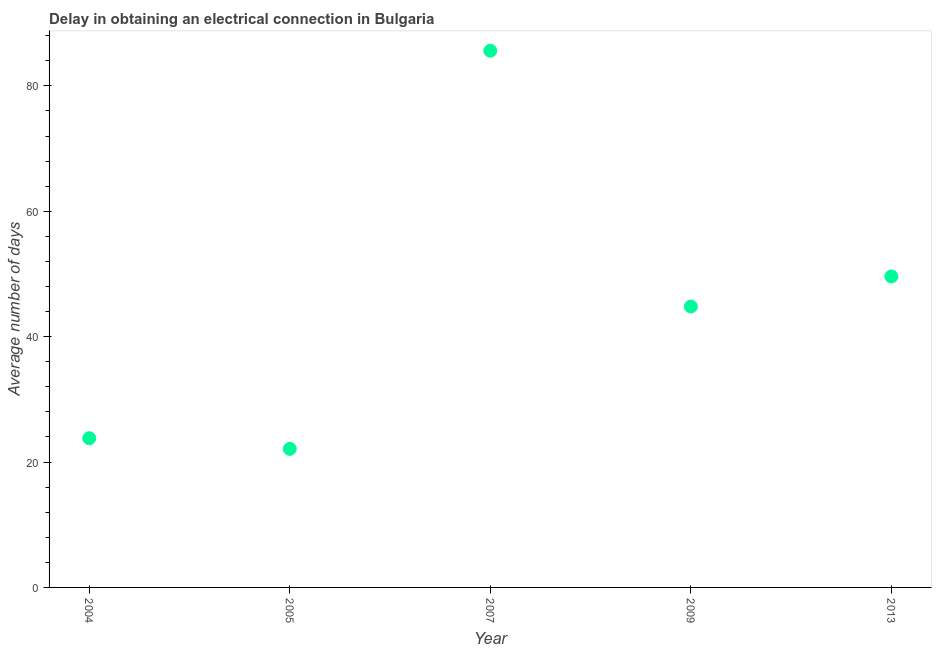What is the dalay in electrical connection in 2009?
Offer a very short reply. 44.8. Across all years, what is the maximum dalay in electrical connection?
Your answer should be very brief. 85.6. Across all years, what is the minimum dalay in electrical connection?
Provide a short and direct response. 22.1. In which year was the dalay in electrical connection maximum?
Provide a short and direct response. 2007. What is the sum of the dalay in electrical connection?
Provide a short and direct response. 225.9. What is the difference between the dalay in electrical connection in 2005 and 2007?
Offer a very short reply. -63.5. What is the average dalay in electrical connection per year?
Your response must be concise. 45.18. What is the median dalay in electrical connection?
Make the answer very short. 44.8. In how many years, is the dalay in electrical connection greater than 84 days?
Your response must be concise. 1. Do a majority of the years between 2009 and 2013 (inclusive) have dalay in electrical connection greater than 84 days?
Offer a terse response. No. What is the ratio of the dalay in electrical connection in 2007 to that in 2009?
Ensure brevity in your answer.  1.91. Is the dalay in electrical connection in 2007 less than that in 2013?
Provide a short and direct response. No. What is the difference between the highest and the second highest dalay in electrical connection?
Offer a very short reply. 36. What is the difference between the highest and the lowest dalay in electrical connection?
Offer a very short reply. 63.5. Does the dalay in electrical connection monotonically increase over the years?
Your answer should be compact. No. How many dotlines are there?
Offer a very short reply. 1. Are the values on the major ticks of Y-axis written in scientific E-notation?
Your answer should be very brief. No. Does the graph contain grids?
Offer a terse response. No. What is the title of the graph?
Ensure brevity in your answer.  Delay in obtaining an electrical connection in Bulgaria. What is the label or title of the Y-axis?
Make the answer very short. Average number of days. What is the Average number of days in 2004?
Keep it short and to the point. 23.8. What is the Average number of days in 2005?
Your answer should be compact. 22.1. What is the Average number of days in 2007?
Your response must be concise. 85.6. What is the Average number of days in 2009?
Ensure brevity in your answer.  44.8. What is the Average number of days in 2013?
Your response must be concise. 49.6. What is the difference between the Average number of days in 2004 and 2005?
Provide a short and direct response. 1.7. What is the difference between the Average number of days in 2004 and 2007?
Your answer should be compact. -61.8. What is the difference between the Average number of days in 2004 and 2009?
Offer a very short reply. -21. What is the difference between the Average number of days in 2004 and 2013?
Offer a very short reply. -25.8. What is the difference between the Average number of days in 2005 and 2007?
Your answer should be compact. -63.5. What is the difference between the Average number of days in 2005 and 2009?
Provide a succinct answer. -22.7. What is the difference between the Average number of days in 2005 and 2013?
Ensure brevity in your answer.  -27.5. What is the difference between the Average number of days in 2007 and 2009?
Give a very brief answer. 40.8. What is the ratio of the Average number of days in 2004 to that in 2005?
Keep it short and to the point. 1.08. What is the ratio of the Average number of days in 2004 to that in 2007?
Your answer should be very brief. 0.28. What is the ratio of the Average number of days in 2004 to that in 2009?
Keep it short and to the point. 0.53. What is the ratio of the Average number of days in 2004 to that in 2013?
Provide a short and direct response. 0.48. What is the ratio of the Average number of days in 2005 to that in 2007?
Provide a short and direct response. 0.26. What is the ratio of the Average number of days in 2005 to that in 2009?
Offer a terse response. 0.49. What is the ratio of the Average number of days in 2005 to that in 2013?
Make the answer very short. 0.45. What is the ratio of the Average number of days in 2007 to that in 2009?
Offer a terse response. 1.91. What is the ratio of the Average number of days in 2007 to that in 2013?
Provide a short and direct response. 1.73. What is the ratio of the Average number of days in 2009 to that in 2013?
Your answer should be compact. 0.9. 